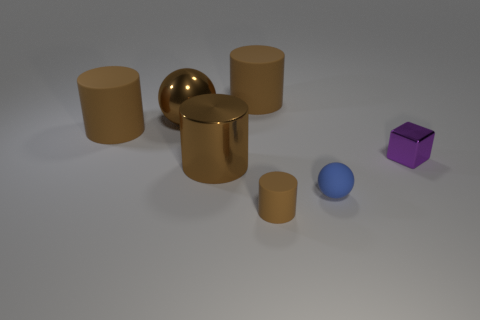Subtract all yellow cylinders. Subtract all brown blocks. How many cylinders are left? 4 Subtract all cyan cylinders. How many brown balls are left? 1 Add 6 large things. How many large browns exist? 0 Subtract all green shiny objects. Subtract all shiny blocks. How many objects are left? 6 Add 4 small brown things. How many small brown things are left? 5 Add 7 gray matte balls. How many gray matte balls exist? 7 Add 3 cyan matte objects. How many objects exist? 10 Subtract all blue balls. How many balls are left? 1 Subtract all big shiny cylinders. How many cylinders are left? 3 Subtract 1 brown balls. How many objects are left? 6 